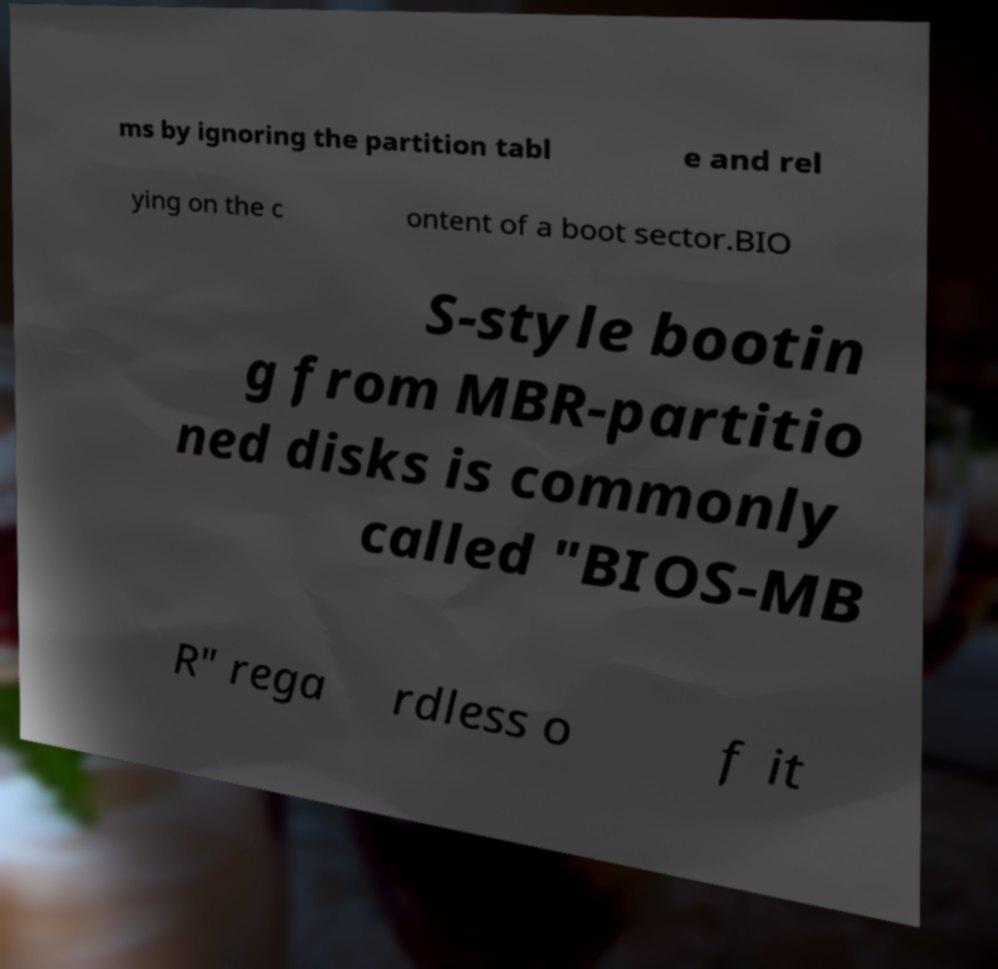Could you extract and type out the text from this image? ms by ignoring the partition tabl e and rel ying on the c ontent of a boot sector.BIO S-style bootin g from MBR-partitio ned disks is commonly called "BIOS-MB R" rega rdless o f it 